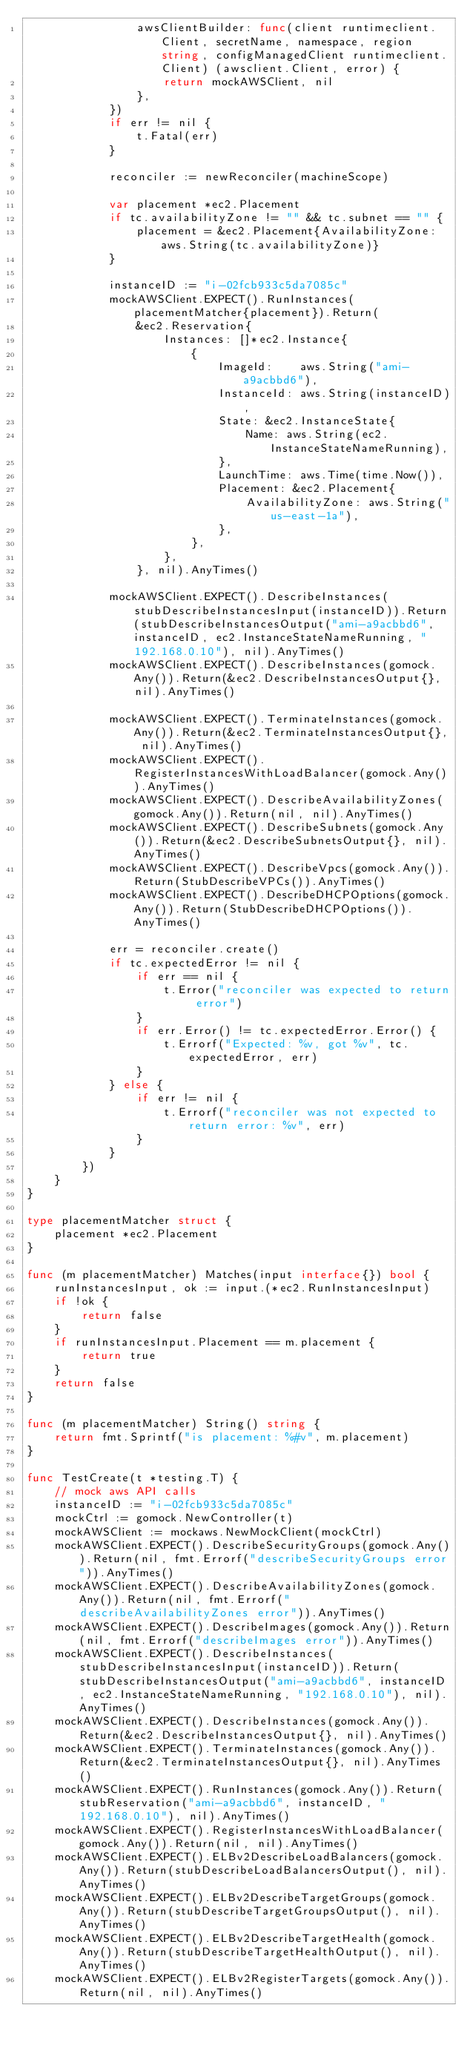Convert code to text. <code><loc_0><loc_0><loc_500><loc_500><_Go_>				awsClientBuilder: func(client runtimeclient.Client, secretName, namespace, region string, configManagedClient runtimeclient.Client) (awsclient.Client, error) {
					return mockAWSClient, nil
				},
			})
			if err != nil {
				t.Fatal(err)
			}

			reconciler := newReconciler(machineScope)

			var placement *ec2.Placement
			if tc.availabilityZone != "" && tc.subnet == "" {
				placement = &ec2.Placement{AvailabilityZone: aws.String(tc.availabilityZone)}
			}

			instanceID := "i-02fcb933c5da7085c"
			mockAWSClient.EXPECT().RunInstances(placementMatcher{placement}).Return(
				&ec2.Reservation{
					Instances: []*ec2.Instance{
						{
							ImageId:    aws.String("ami-a9acbbd6"),
							InstanceId: aws.String(instanceID),
							State: &ec2.InstanceState{
								Name: aws.String(ec2.InstanceStateNameRunning),
							},
							LaunchTime: aws.Time(time.Now()),
							Placement: &ec2.Placement{
								AvailabilityZone: aws.String("us-east-1a"),
							},
						},
					},
				}, nil).AnyTimes()

			mockAWSClient.EXPECT().DescribeInstances(stubDescribeInstancesInput(instanceID)).Return(stubDescribeInstancesOutput("ami-a9acbbd6", instanceID, ec2.InstanceStateNameRunning, "192.168.0.10"), nil).AnyTimes()
			mockAWSClient.EXPECT().DescribeInstances(gomock.Any()).Return(&ec2.DescribeInstancesOutput{}, nil).AnyTimes()

			mockAWSClient.EXPECT().TerminateInstances(gomock.Any()).Return(&ec2.TerminateInstancesOutput{}, nil).AnyTimes()
			mockAWSClient.EXPECT().RegisterInstancesWithLoadBalancer(gomock.Any()).AnyTimes()
			mockAWSClient.EXPECT().DescribeAvailabilityZones(gomock.Any()).Return(nil, nil).AnyTimes()
			mockAWSClient.EXPECT().DescribeSubnets(gomock.Any()).Return(&ec2.DescribeSubnetsOutput{}, nil).AnyTimes()
			mockAWSClient.EXPECT().DescribeVpcs(gomock.Any()).Return(StubDescribeVPCs()).AnyTimes()
			mockAWSClient.EXPECT().DescribeDHCPOptions(gomock.Any()).Return(StubDescribeDHCPOptions()).AnyTimes()

			err = reconciler.create()
			if tc.expectedError != nil {
				if err == nil {
					t.Error("reconciler was expected to return error")
				}
				if err.Error() != tc.expectedError.Error() {
					t.Errorf("Expected: %v, got %v", tc.expectedError, err)
				}
			} else {
				if err != nil {
					t.Errorf("reconciler was not expected to return error: %v", err)
				}
			}
		})
	}
}

type placementMatcher struct {
	placement *ec2.Placement
}

func (m placementMatcher) Matches(input interface{}) bool {
	runInstancesInput, ok := input.(*ec2.RunInstancesInput)
	if !ok {
		return false
	}
	if runInstancesInput.Placement == m.placement {
		return true
	}
	return false
}

func (m placementMatcher) String() string {
	return fmt.Sprintf("is placement: %#v", m.placement)
}

func TestCreate(t *testing.T) {
	// mock aws API calls
	instanceID := "i-02fcb933c5da7085c"
	mockCtrl := gomock.NewController(t)
	mockAWSClient := mockaws.NewMockClient(mockCtrl)
	mockAWSClient.EXPECT().DescribeSecurityGroups(gomock.Any()).Return(nil, fmt.Errorf("describeSecurityGroups error")).AnyTimes()
	mockAWSClient.EXPECT().DescribeAvailabilityZones(gomock.Any()).Return(nil, fmt.Errorf("describeAvailabilityZones error")).AnyTimes()
	mockAWSClient.EXPECT().DescribeImages(gomock.Any()).Return(nil, fmt.Errorf("describeImages error")).AnyTimes()
	mockAWSClient.EXPECT().DescribeInstances(stubDescribeInstancesInput(instanceID)).Return(stubDescribeInstancesOutput("ami-a9acbbd6", instanceID, ec2.InstanceStateNameRunning, "192.168.0.10"), nil).AnyTimes()
	mockAWSClient.EXPECT().DescribeInstances(gomock.Any()).Return(&ec2.DescribeInstancesOutput{}, nil).AnyTimes()
	mockAWSClient.EXPECT().TerminateInstances(gomock.Any()).Return(&ec2.TerminateInstancesOutput{}, nil).AnyTimes()
	mockAWSClient.EXPECT().RunInstances(gomock.Any()).Return(stubReservation("ami-a9acbbd6", instanceID, "192.168.0.10"), nil).AnyTimes()
	mockAWSClient.EXPECT().RegisterInstancesWithLoadBalancer(gomock.Any()).Return(nil, nil).AnyTimes()
	mockAWSClient.EXPECT().ELBv2DescribeLoadBalancers(gomock.Any()).Return(stubDescribeLoadBalancersOutput(), nil).AnyTimes()
	mockAWSClient.EXPECT().ELBv2DescribeTargetGroups(gomock.Any()).Return(stubDescribeTargetGroupsOutput(), nil).AnyTimes()
	mockAWSClient.EXPECT().ELBv2DescribeTargetHealth(gomock.Any()).Return(stubDescribeTargetHealthOutput(), nil).AnyTimes()
	mockAWSClient.EXPECT().ELBv2RegisterTargets(gomock.Any()).Return(nil, nil).AnyTimes()</code> 